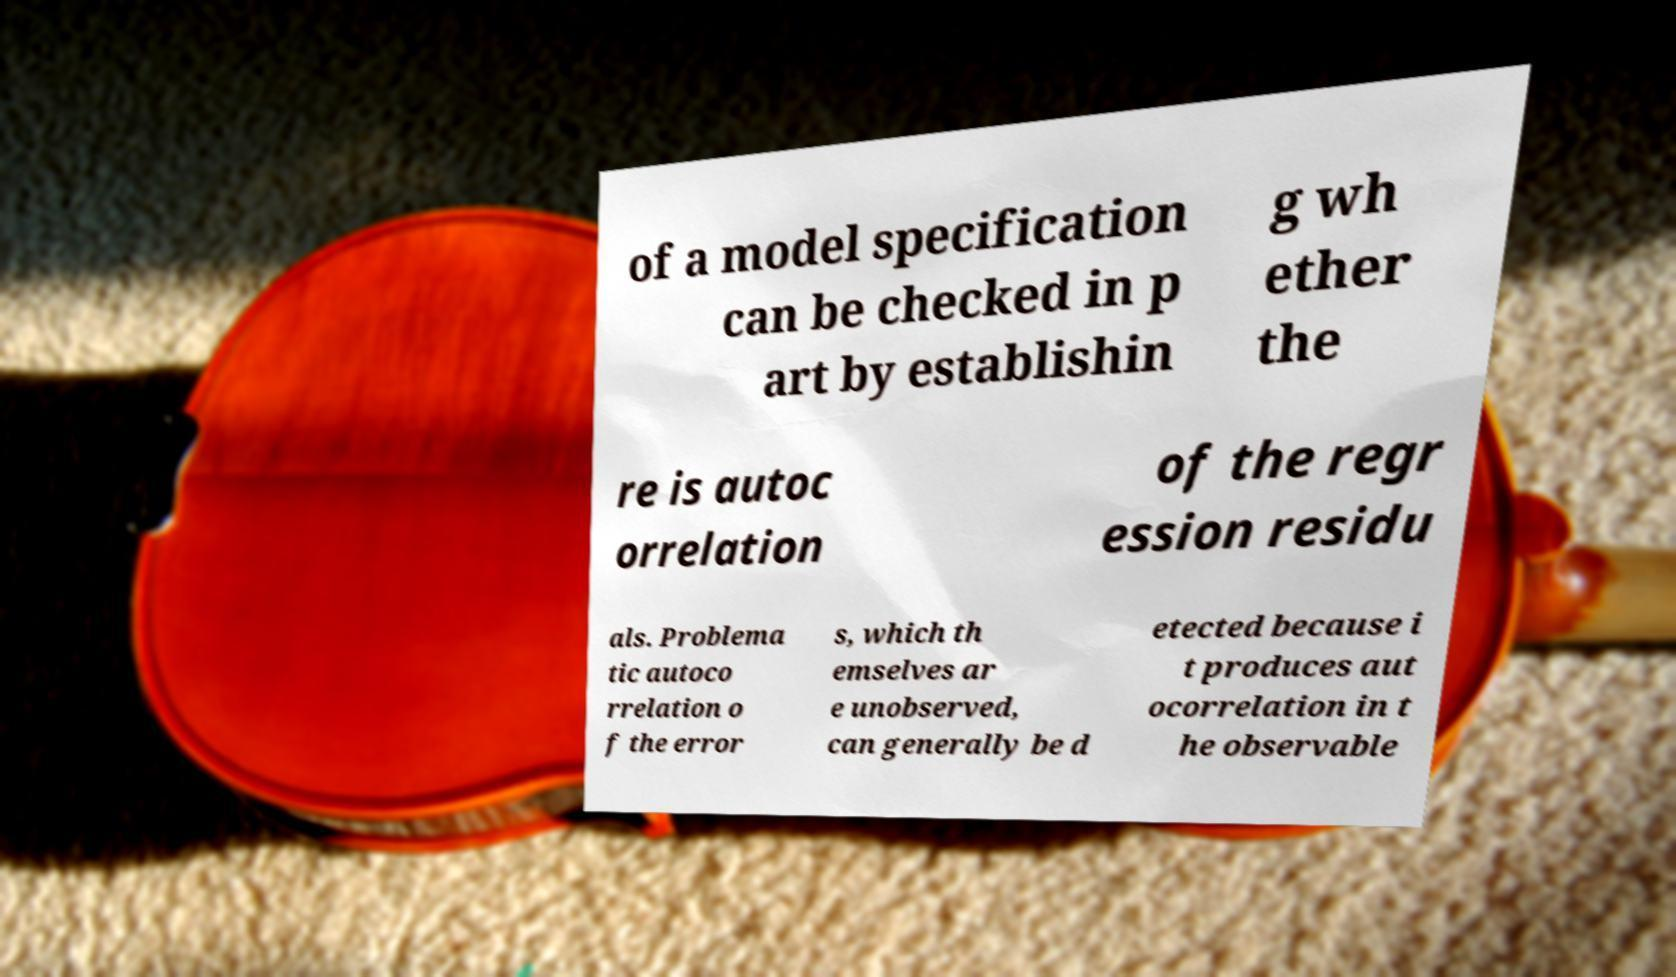Could you assist in decoding the text presented in this image and type it out clearly? of a model specification can be checked in p art by establishin g wh ether the re is autoc orrelation of the regr ession residu als. Problema tic autoco rrelation o f the error s, which th emselves ar e unobserved, can generally be d etected because i t produces aut ocorrelation in t he observable 